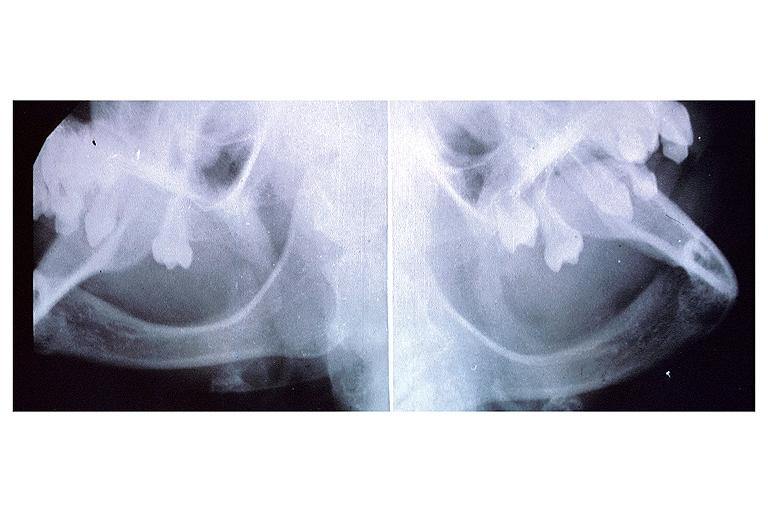what is present?
Answer the question using a single word or phrase. Oral 